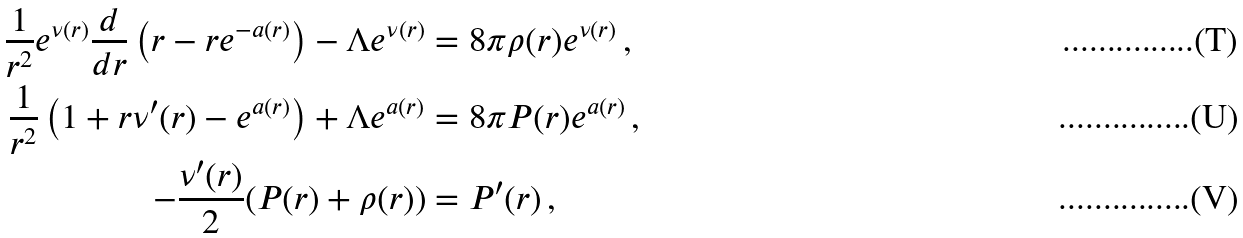<formula> <loc_0><loc_0><loc_500><loc_500>\frac { 1 } { r ^ { 2 } } e ^ { \nu ( r ) } \frac { d } { d r } \left ( r - r e ^ { - a ( r ) } \right ) - \Lambda e ^ { \nu ( r ) } & = 8 \pi \rho ( r ) e ^ { \nu ( r ) } \, , \\ \frac { 1 } { r ^ { 2 } } \left ( 1 + r \nu ^ { \prime } ( r ) - e ^ { a ( r ) } \right ) + \Lambda e ^ { a ( r ) } & = 8 \pi P ( r ) e ^ { a ( r ) } \, , \\ - \frac { \nu ^ { \prime } ( r ) } { 2 } ( P ( r ) + \rho ( r ) ) & = P ^ { \prime } ( r ) \, ,</formula> 